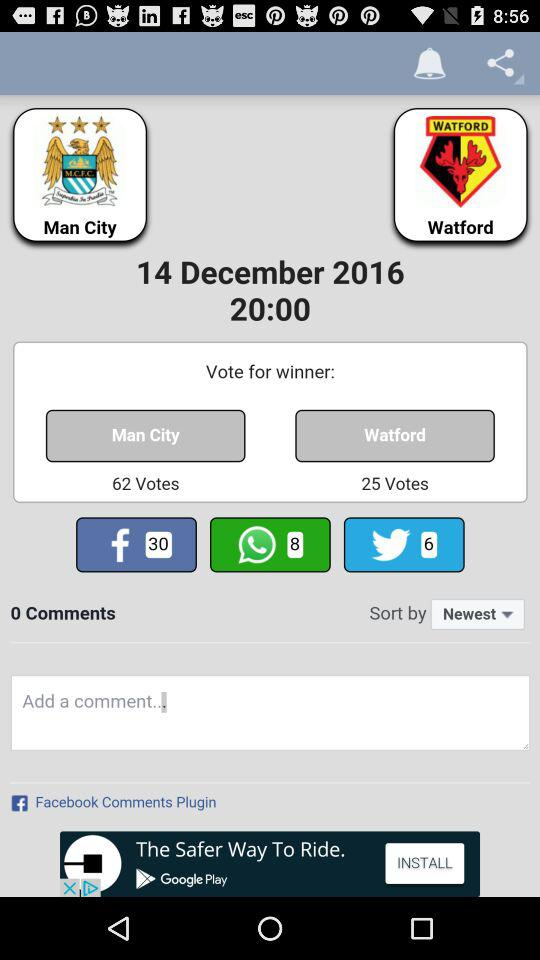What is the number of votes for "Man City"? There are 62 votes for "Man City". 